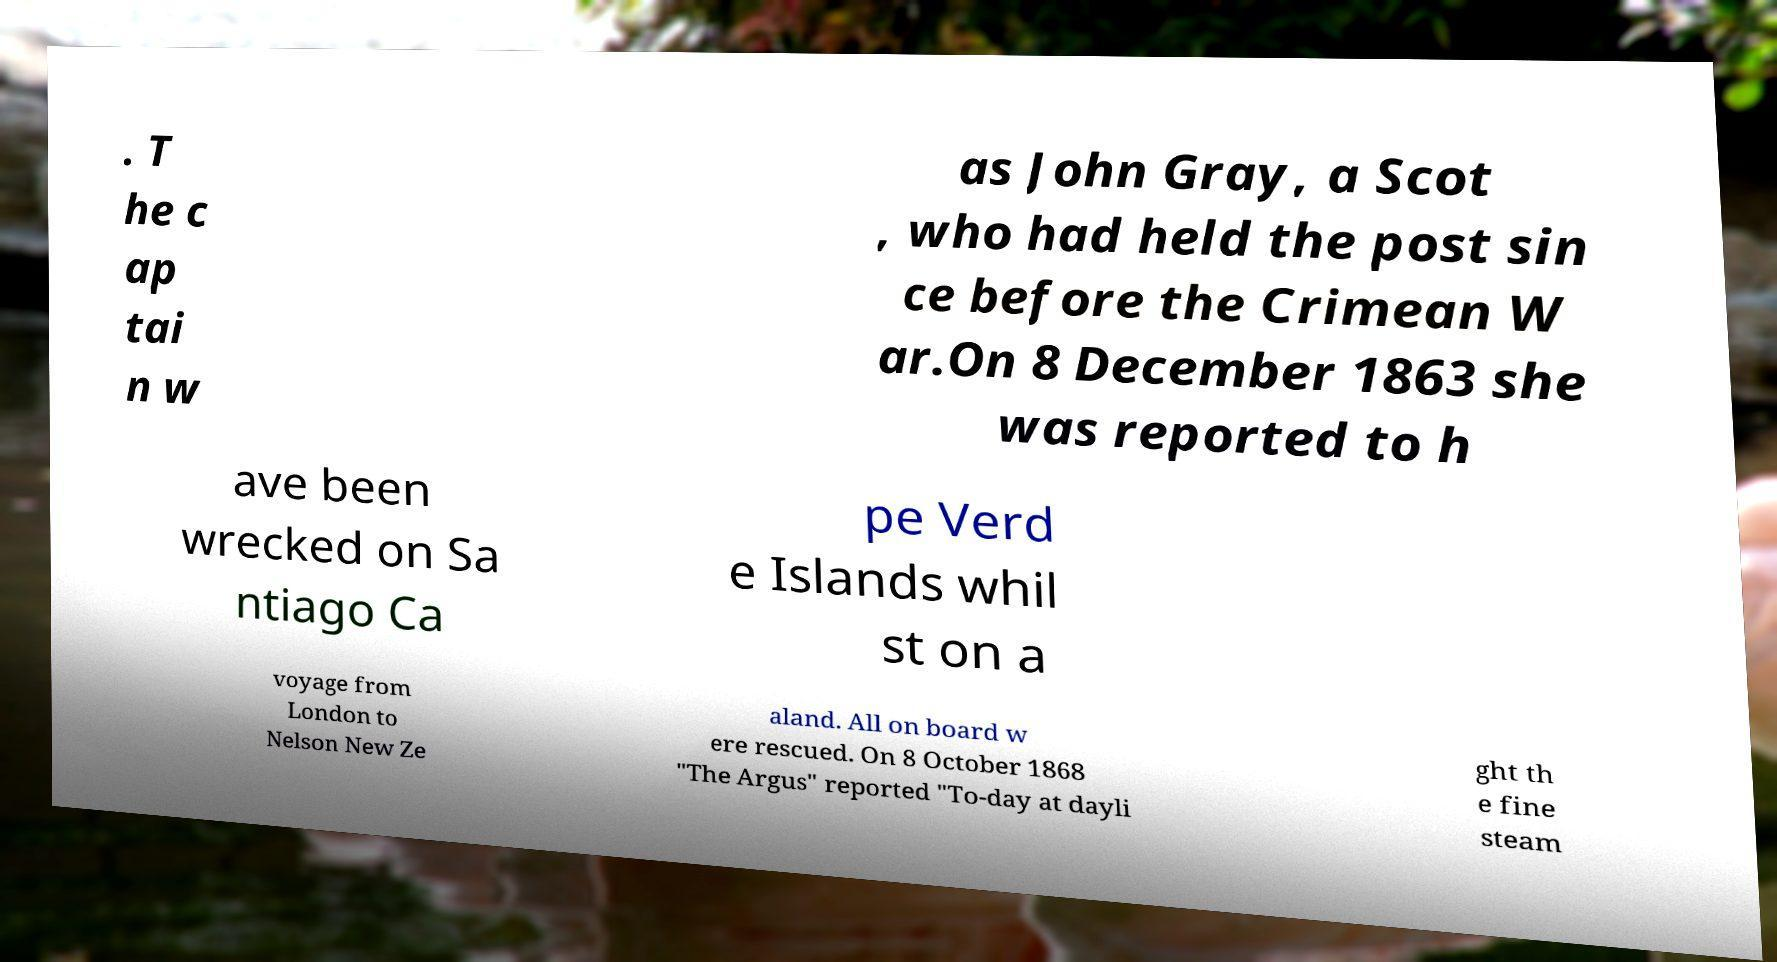Can you read and provide the text displayed in the image?This photo seems to have some interesting text. Can you extract and type it out for me? . T he c ap tai n w as John Gray, a Scot , who had held the post sin ce before the Crimean W ar.On 8 December 1863 she was reported to h ave been wrecked on Sa ntiago Ca pe Verd e Islands whil st on a voyage from London to Nelson New Ze aland. All on board w ere rescued. On 8 October 1868 "The Argus" reported "To-day at dayli ght th e fine steam 